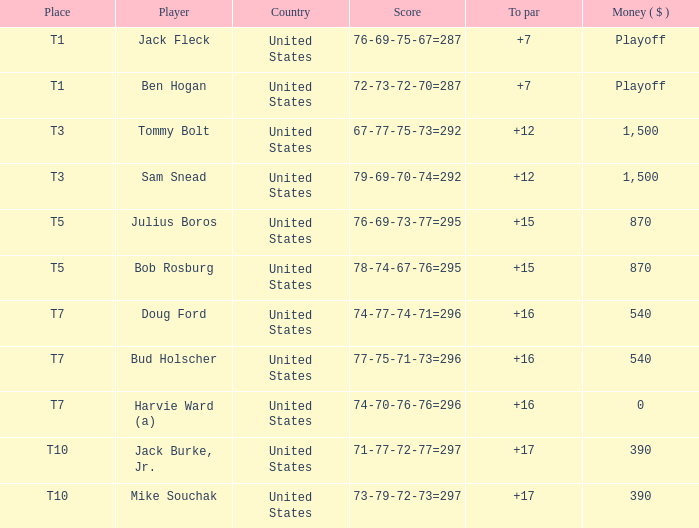What is the sum of all scores equal to par for player bob rosburg? 15.0. 